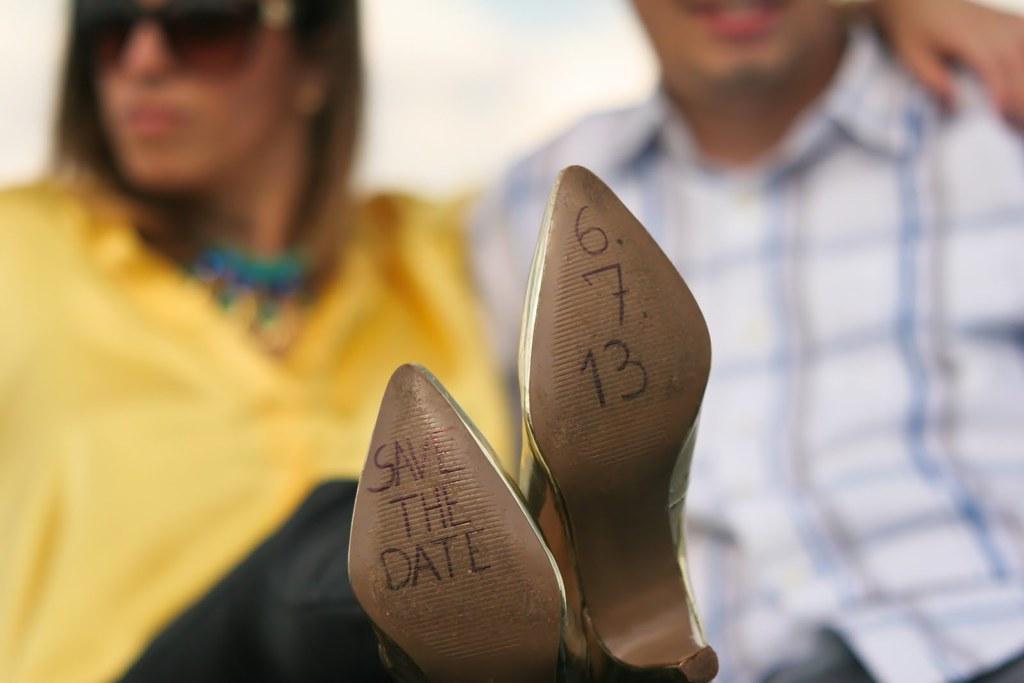In one or two sentences, can you explain what this image depicts? In this image we can see texts and digits written on a footwear. In the background there are few persons. 